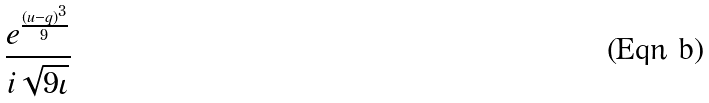Convert formula to latex. <formula><loc_0><loc_0><loc_500><loc_500>\frac { e ^ { \frac { ( u - q ) ^ { 3 } } { 9 } } } { i \sqrt { 9 \iota } }</formula> 